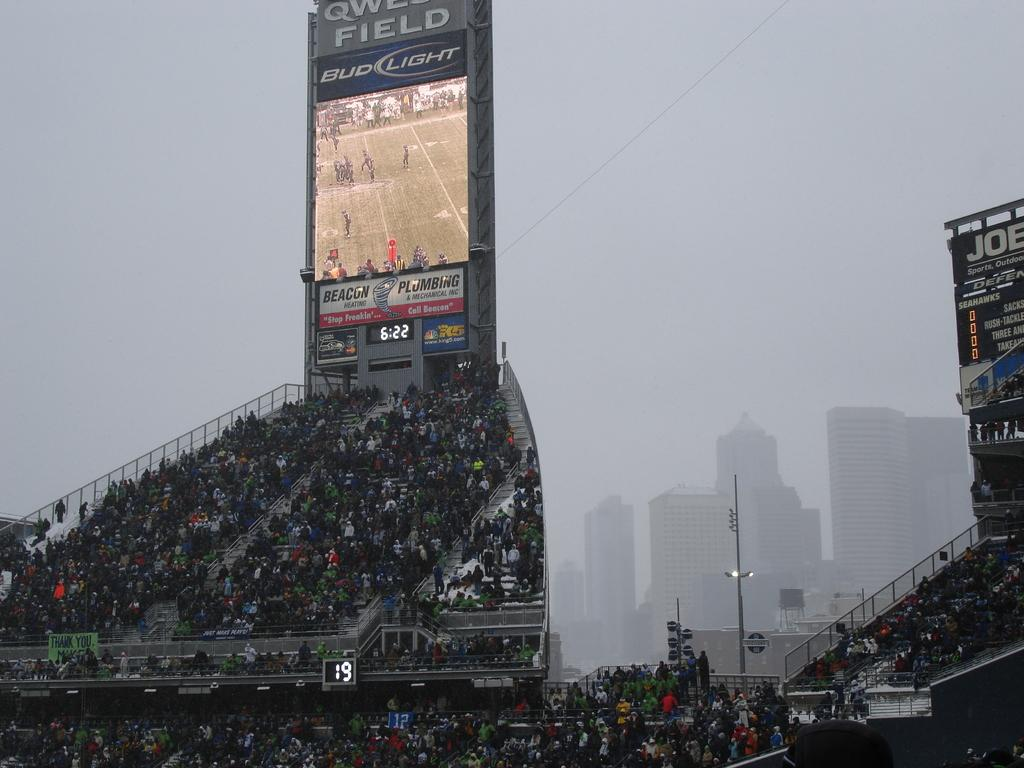<image>
Describe the image concisely. The time shown on the stand is 6:22. 